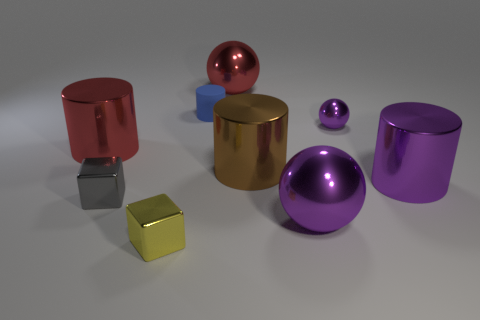What is the size of the sphere that is both to the right of the brown object and behind the brown cylinder?
Offer a terse response. Small. Are there any large purple matte objects that have the same shape as the yellow thing?
Provide a short and direct response. No. Is there any other thing that is the same shape as the large brown metallic thing?
Your response must be concise. Yes. What is the cube that is in front of the large ball in front of the red metal object left of the tiny yellow block made of?
Offer a very short reply. Metal. Is there a red metal object of the same size as the gray metallic block?
Your answer should be compact. No. What color is the large thing that is behind the large red thing in front of the red metallic ball?
Your answer should be compact. Red. How many things are there?
Provide a short and direct response. 9. Is the color of the tiny cylinder the same as the small sphere?
Your answer should be compact. No. Is the number of shiny cubes that are behind the tiny blue rubber cylinder less than the number of gray metallic blocks that are behind the brown metallic thing?
Provide a succinct answer. No. What color is the tiny shiny ball?
Your answer should be compact. Purple. 